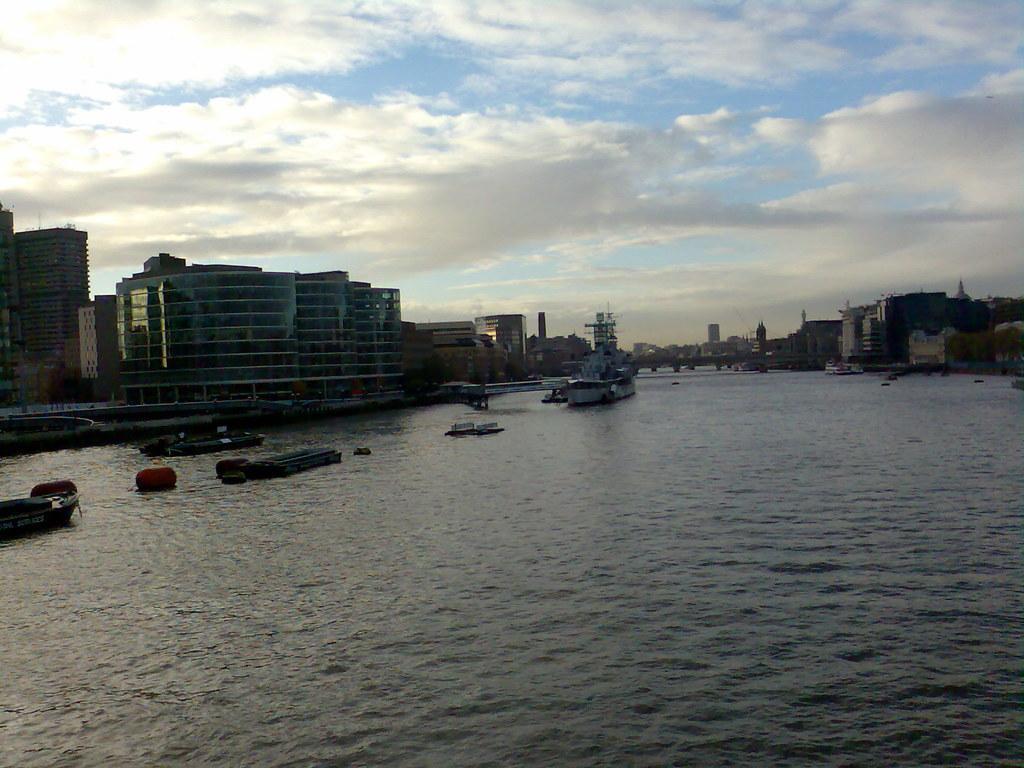Can you describe this image briefly? In this image we can see boats on the surface of water. Background of the image buildings are there. At the top of the image sky is there with clouds. 